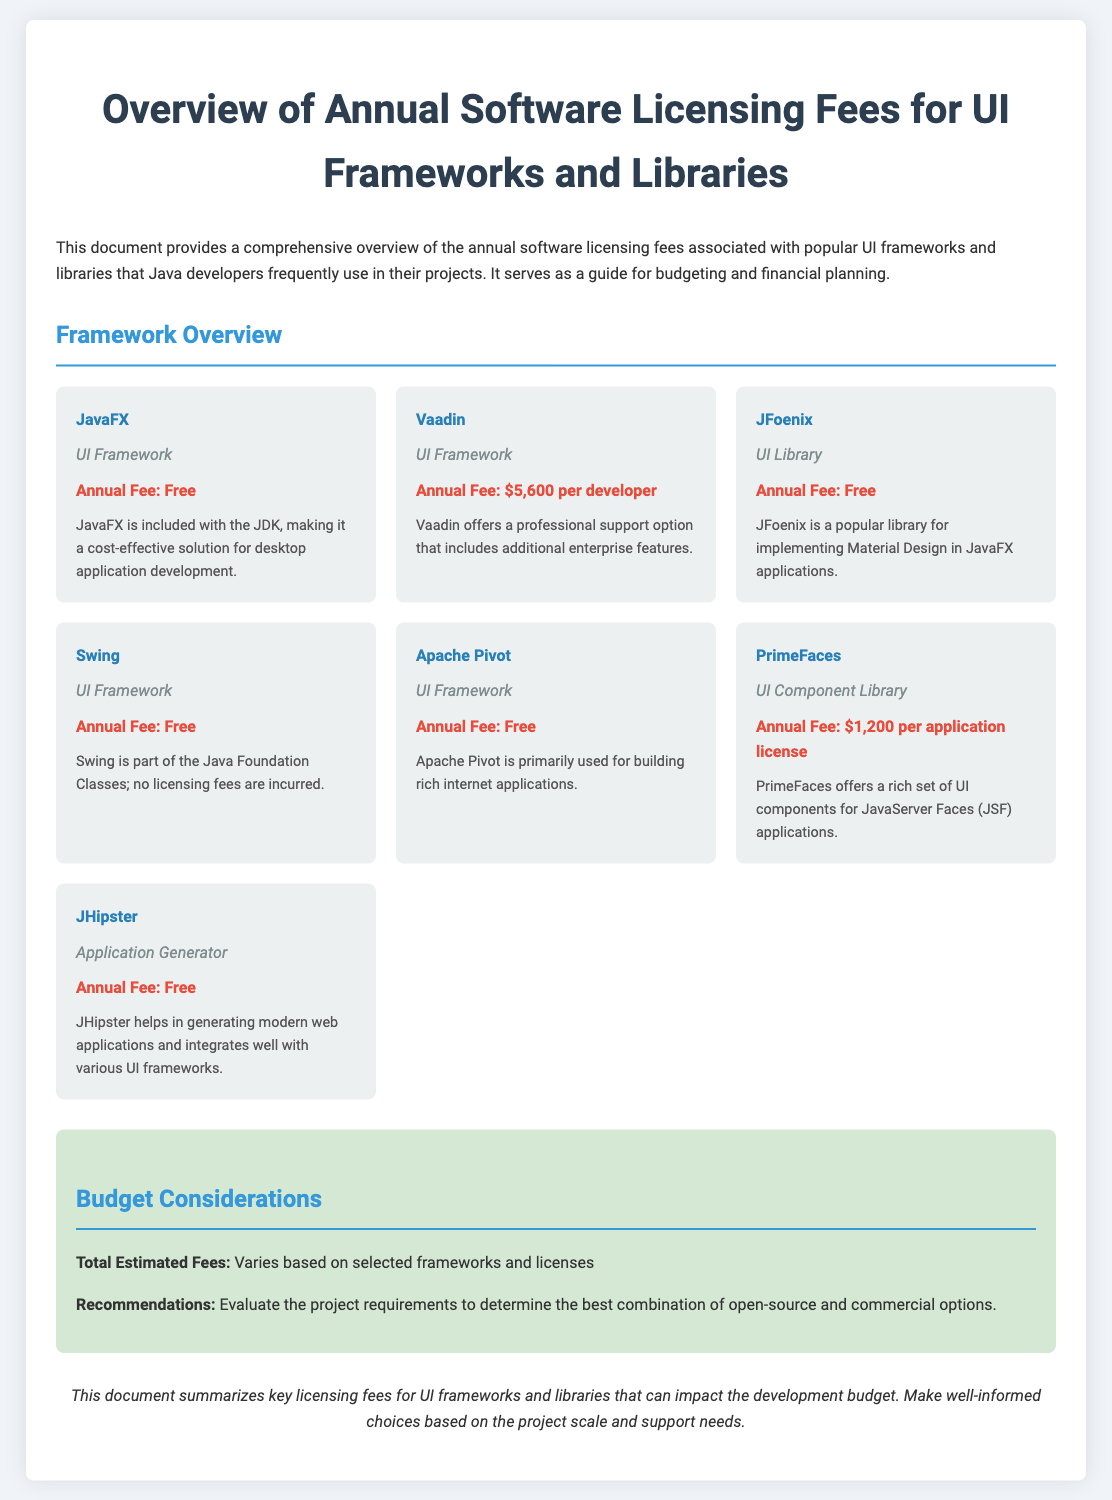What is the annual fee for Vaadin? The annual fee for Vaadin is clearly stated in the document as $5,600 per developer.
Answer: $5,600 per developer What type of framework is PrimeFaces? The document categorizes PrimeFaces under UI Component Library, which defines its type.
Answer: UI Component Library What are the total estimated fees based on in the document? The total estimated fees vary based on the selected frameworks and licenses mentioned in the budget section.
Answer: Varies Which framework is provided free of charge and included with the JDK? The document specifies that JavaFX has no annual fee and is included with the JDK.
Answer: JavaFX How much is the annual fee for a PrimeFaces application license? The annual fee for a PrimeFaces application license is listed in the document as $1,200.
Answer: $1,200 What is the purpose of JHipster according to the document? The document indicates that JHipster helps in generating modern web applications.
Answer: Generating modern web applications What does the budget section recommend? The recommendations in the budget section suggest evaluating project requirements for the best options.
Answer: Evaluate the project requirements How many frameworks are mentioned in the overview section? The document lists a total of seven frameworks and libraries in the overview section.
Answer: Seven 